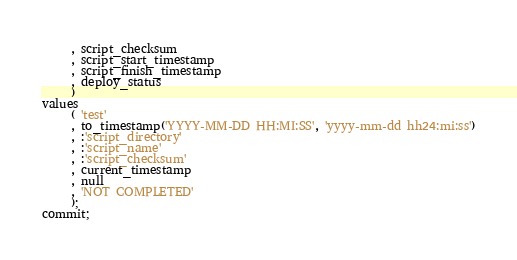<code> <loc_0><loc_0><loc_500><loc_500><_SQL_>     , script_checksum
     , script_start_timestamp
     , script_finish_timestamp
     , deploy_status
     )
values
     ( 'test'
     , to_timestamp('YYYY-MM-DD HH:MI:SS', 'yyyy-mm-dd hh24:mi:ss')
     , :'script_directory'
     , :'script_name'
     , :'script_checksum'
     , current_timestamp
     , null
     , 'NOT COMPLETED'
     );
commit;
</code> 